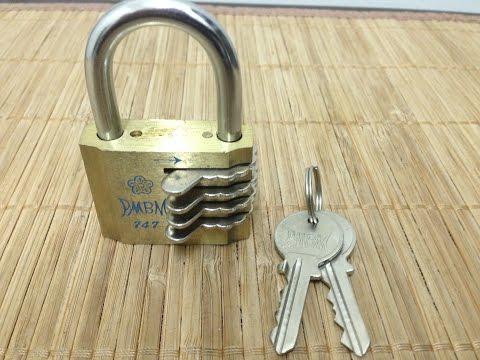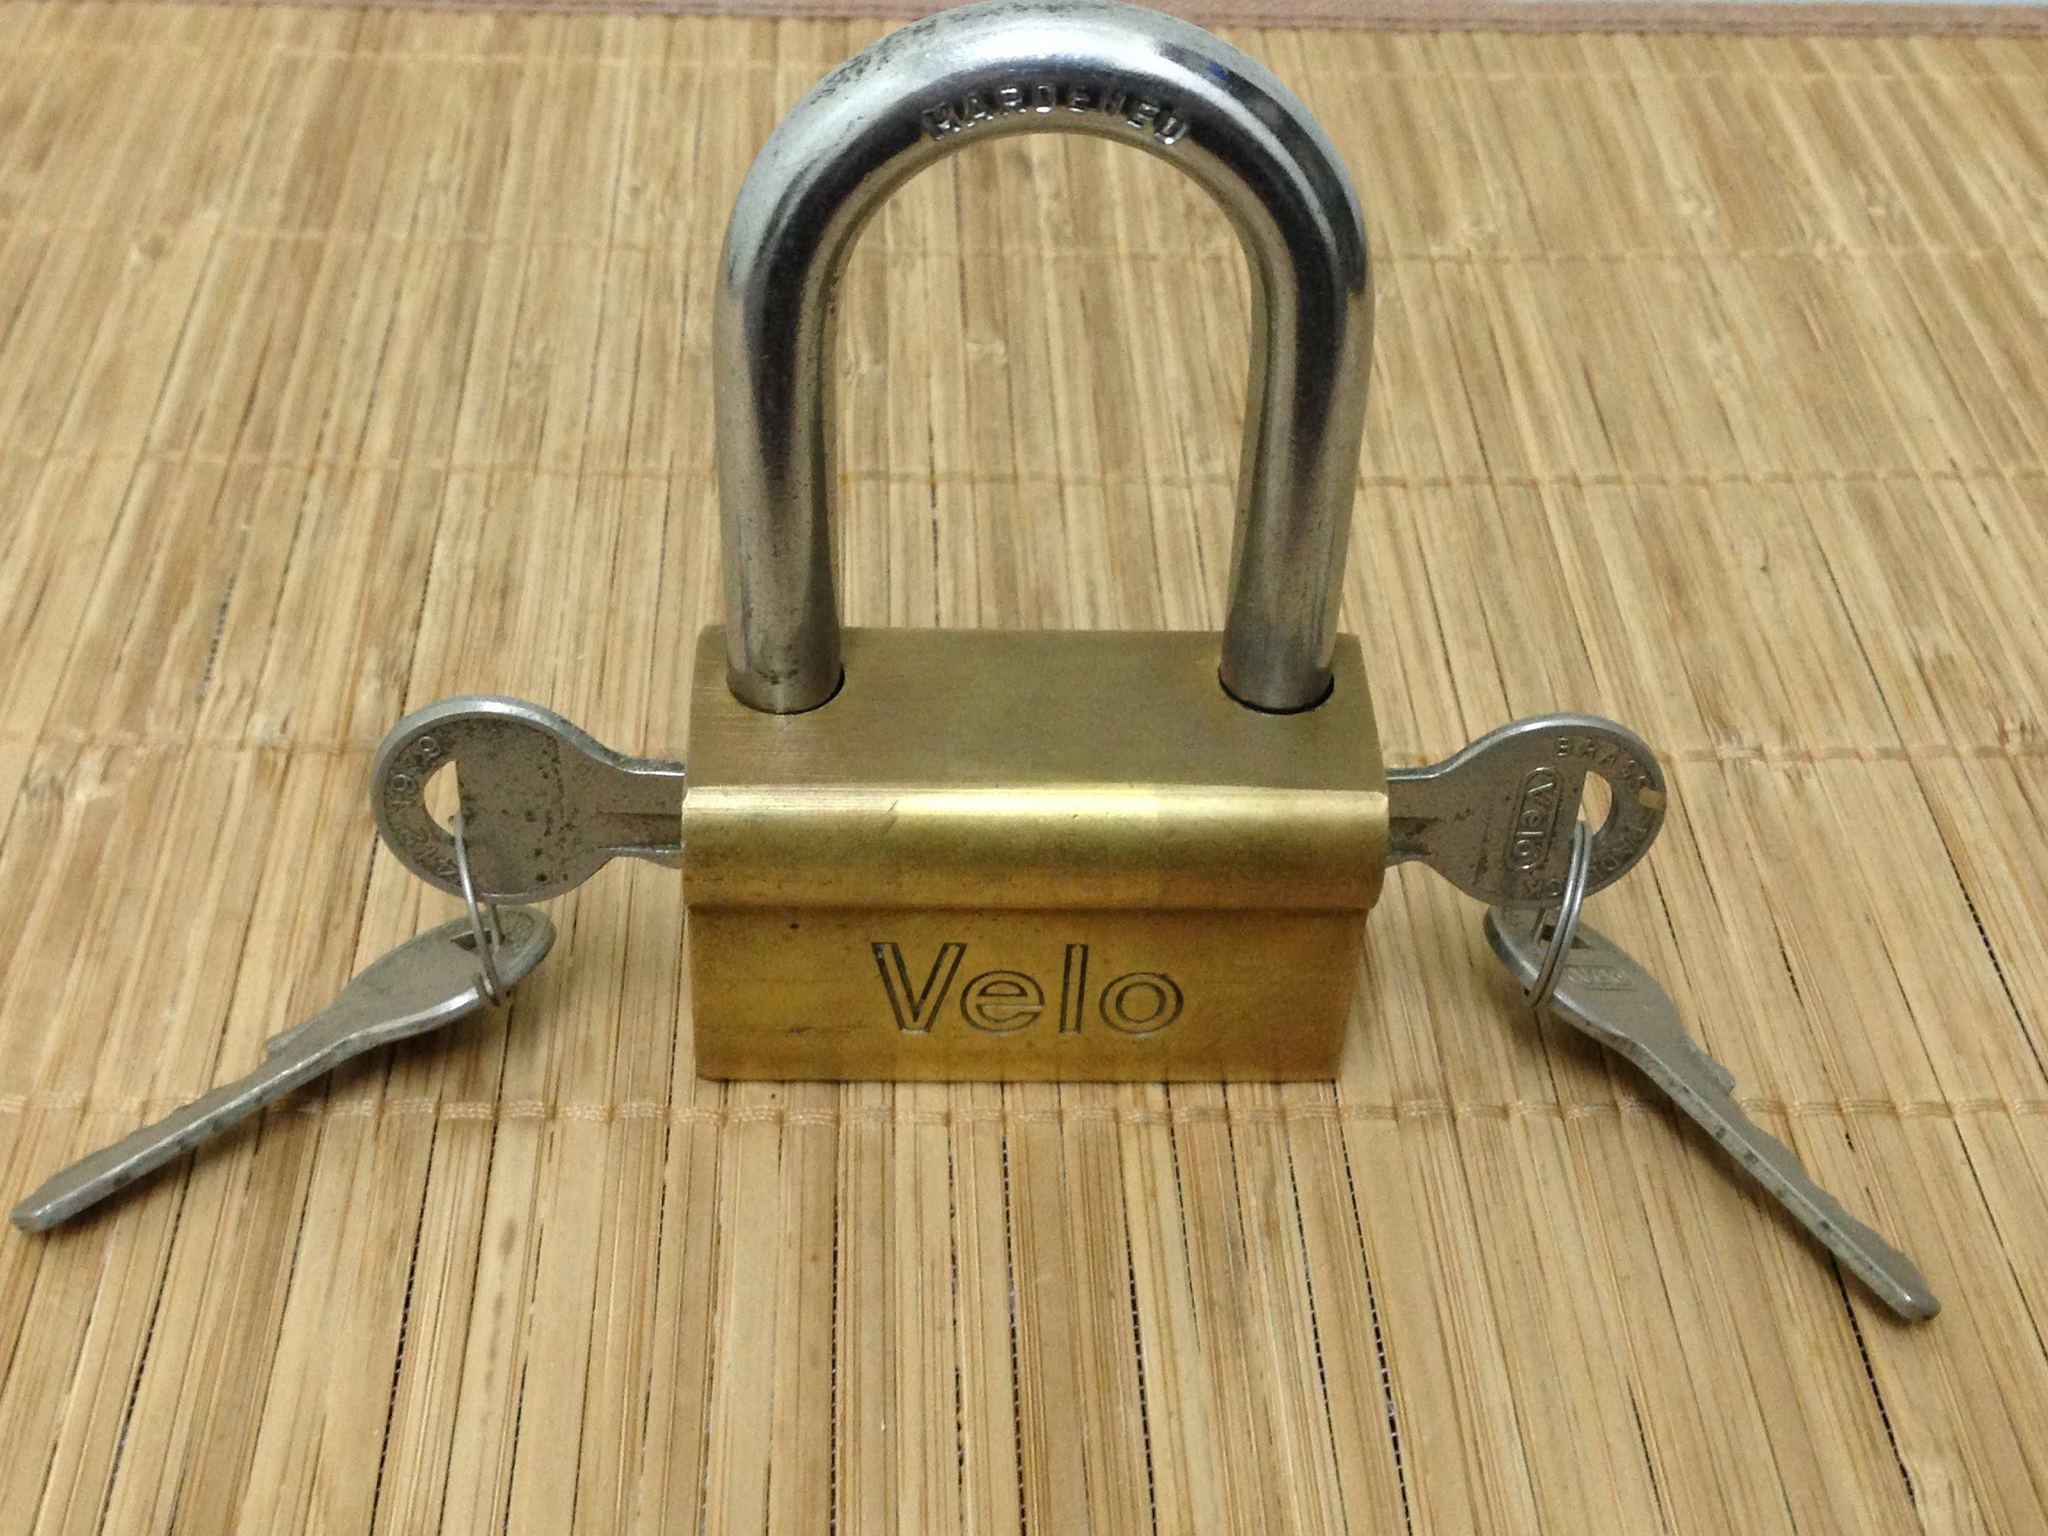The first image is the image on the left, the second image is the image on the right. For the images displayed, is the sentence "An image shows one lock with two keys inserted into it." factually correct? Answer yes or no. Yes. 